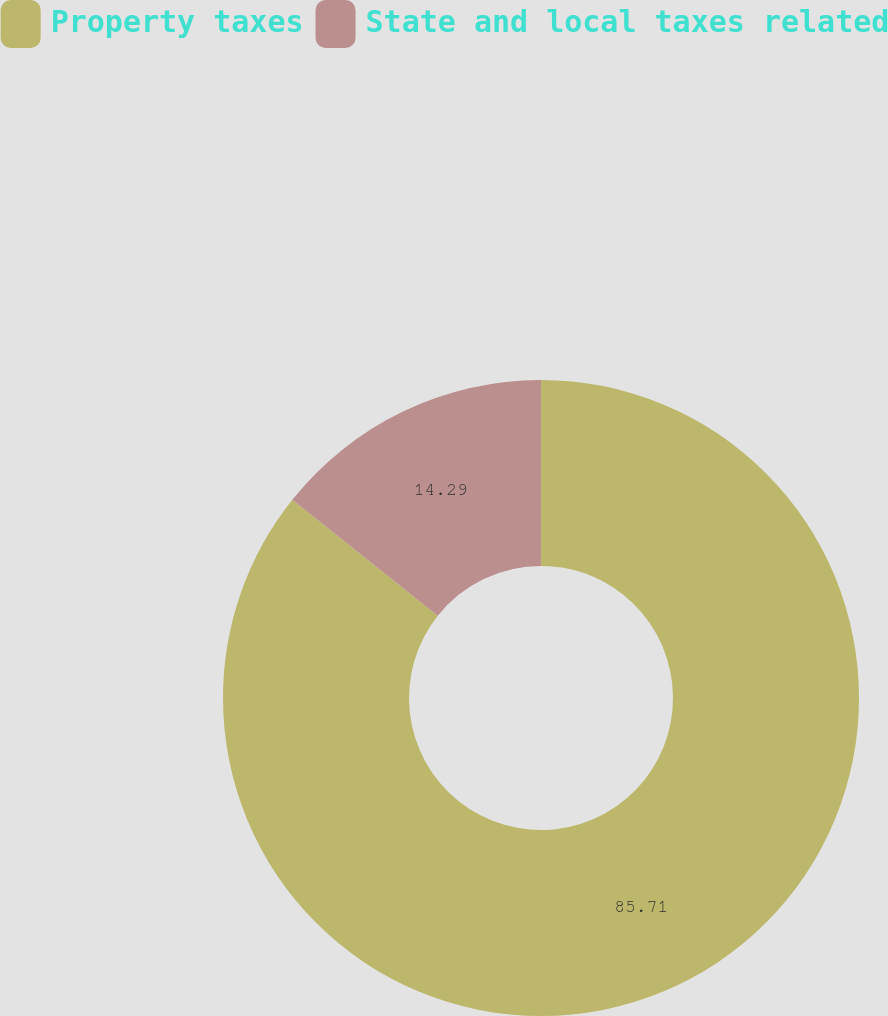Convert chart. <chart><loc_0><loc_0><loc_500><loc_500><pie_chart><fcel>Property taxes<fcel>State and local taxes related<nl><fcel>85.71%<fcel>14.29%<nl></chart> 